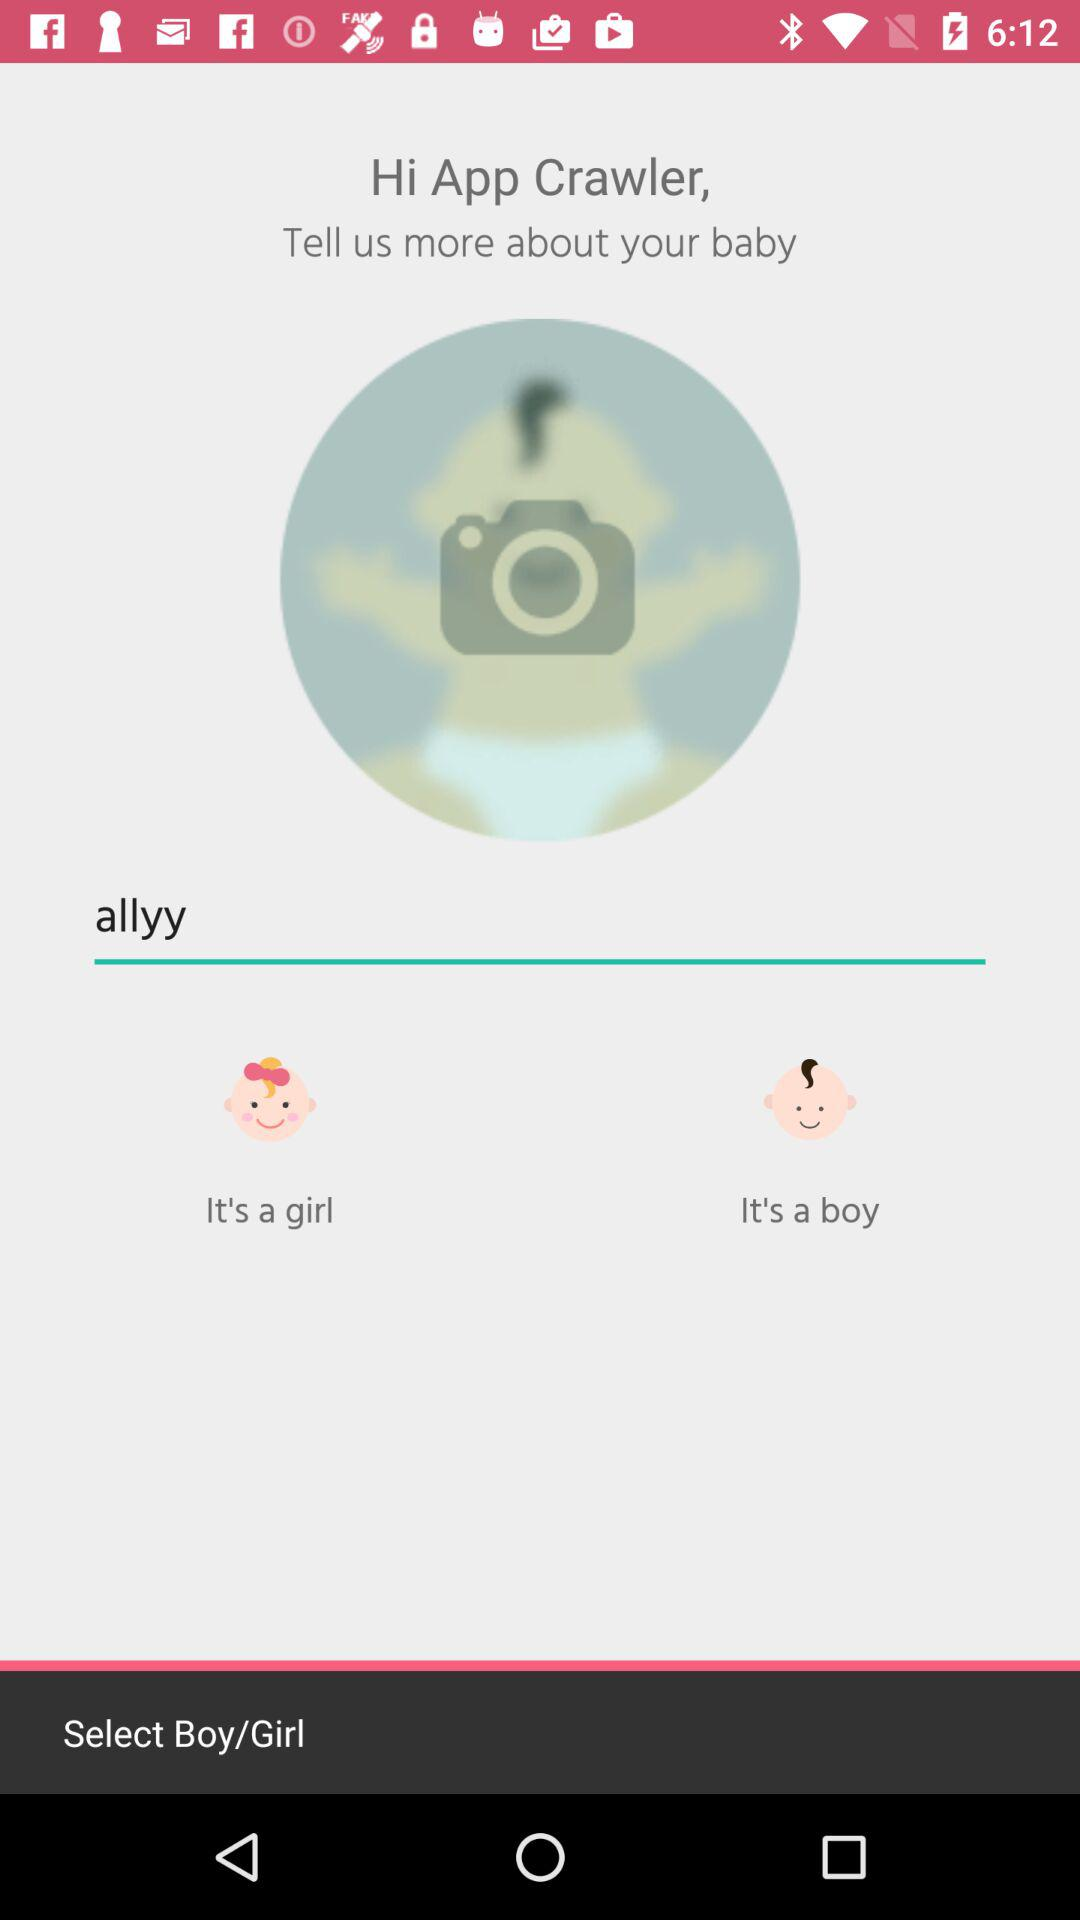What are the gender options? The gender options are "It's a girl" and "It's a boy". 